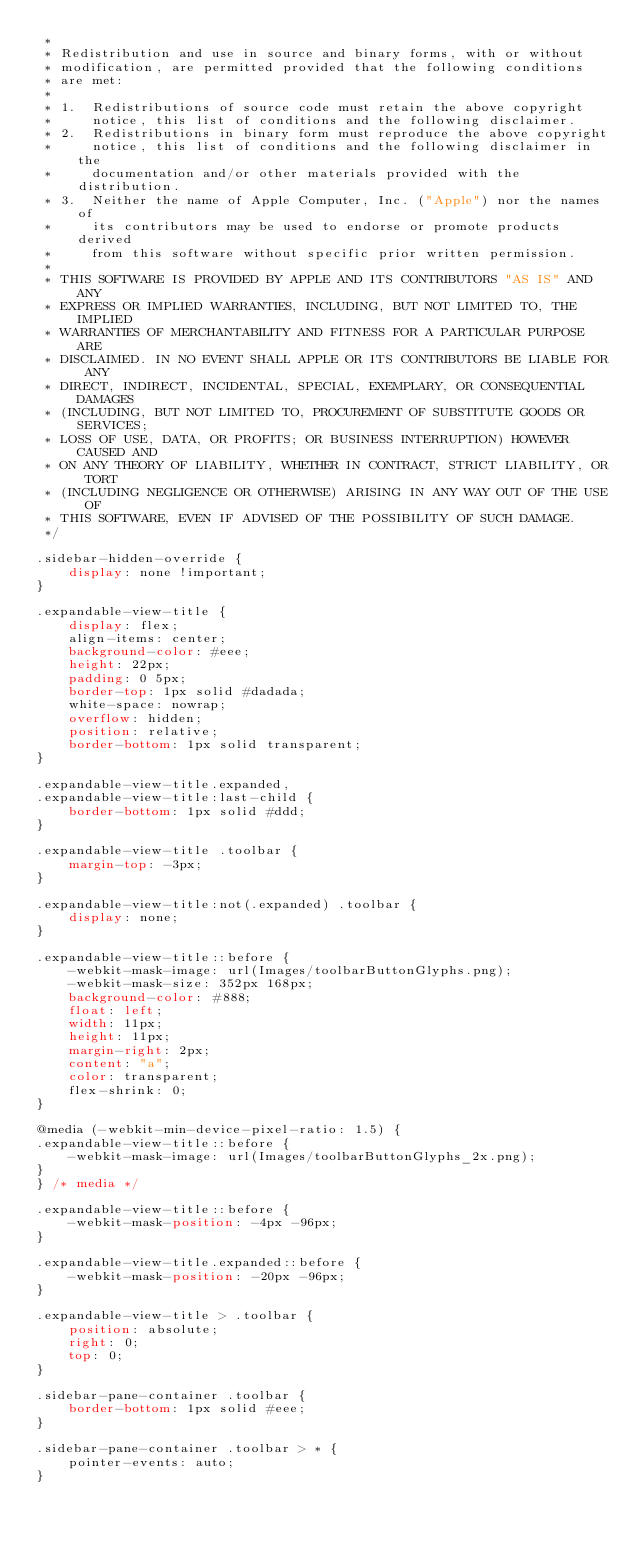<code> <loc_0><loc_0><loc_500><loc_500><_CSS_> *
 * Redistribution and use in source and binary forms, with or without
 * modification, are permitted provided that the following conditions
 * are met:
 *
 * 1.  Redistributions of source code must retain the above copyright
 *     notice, this list of conditions and the following disclaimer.
 * 2.  Redistributions in binary form must reproduce the above copyright
 *     notice, this list of conditions and the following disclaimer in the
 *     documentation and/or other materials provided with the distribution.
 * 3.  Neither the name of Apple Computer, Inc. ("Apple") nor the names of
 *     its contributors may be used to endorse or promote products derived
 *     from this software without specific prior written permission.
 *
 * THIS SOFTWARE IS PROVIDED BY APPLE AND ITS CONTRIBUTORS "AS IS" AND ANY
 * EXPRESS OR IMPLIED WARRANTIES, INCLUDING, BUT NOT LIMITED TO, THE IMPLIED
 * WARRANTIES OF MERCHANTABILITY AND FITNESS FOR A PARTICULAR PURPOSE ARE
 * DISCLAIMED. IN NO EVENT SHALL APPLE OR ITS CONTRIBUTORS BE LIABLE FOR ANY
 * DIRECT, INDIRECT, INCIDENTAL, SPECIAL, EXEMPLARY, OR CONSEQUENTIAL DAMAGES
 * (INCLUDING, BUT NOT LIMITED TO, PROCUREMENT OF SUBSTITUTE GOODS OR SERVICES;
 * LOSS OF USE, DATA, OR PROFITS; OR BUSINESS INTERRUPTION) HOWEVER CAUSED AND
 * ON ANY THEORY OF LIABILITY, WHETHER IN CONTRACT, STRICT LIABILITY, OR TORT
 * (INCLUDING NEGLIGENCE OR OTHERWISE) ARISING IN ANY WAY OUT OF THE USE OF
 * THIS SOFTWARE, EVEN IF ADVISED OF THE POSSIBILITY OF SUCH DAMAGE.
 */

.sidebar-hidden-override {
    display: none !important;
}

.expandable-view-title {
    display: flex;
    align-items: center;
    background-color: #eee;
    height: 22px;
    padding: 0 5px;
    border-top: 1px solid #dadada;
    white-space: nowrap;
    overflow: hidden;
    position: relative;
    border-bottom: 1px solid transparent;
}

.expandable-view-title.expanded,
.expandable-view-title:last-child {
    border-bottom: 1px solid #ddd;
}

.expandable-view-title .toolbar {
    margin-top: -3px;
}

.expandable-view-title:not(.expanded) .toolbar {
    display: none;
}

.expandable-view-title::before {
    -webkit-mask-image: url(Images/toolbarButtonGlyphs.png);
    -webkit-mask-size: 352px 168px;
    background-color: #888;
    float: left;
    width: 11px;
    height: 11px;
    margin-right: 2px;
    content: "a";
    color: transparent;
    flex-shrink: 0;
}

@media (-webkit-min-device-pixel-ratio: 1.5) {
.expandable-view-title::before {
    -webkit-mask-image: url(Images/toolbarButtonGlyphs_2x.png);
}
} /* media */

.expandable-view-title::before {
    -webkit-mask-position: -4px -96px;
}

.expandable-view-title.expanded::before {
    -webkit-mask-position: -20px -96px;
}

.expandable-view-title > .toolbar {
    position: absolute;
    right: 0;
    top: 0;
}

.sidebar-pane-container .toolbar {
    border-bottom: 1px solid #eee;
}

.sidebar-pane-container .toolbar > * {
    pointer-events: auto;
}
</code> 